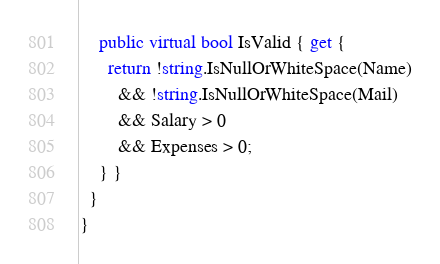<code> <loc_0><loc_0><loc_500><loc_500><_C#_>
    public virtual bool IsValid { get {
      return !string.IsNullOrWhiteSpace(Name)
        && !string.IsNullOrWhiteSpace(Mail)
        && Salary > 0
        && Expenses > 0;
    } }
  }
}
</code> 